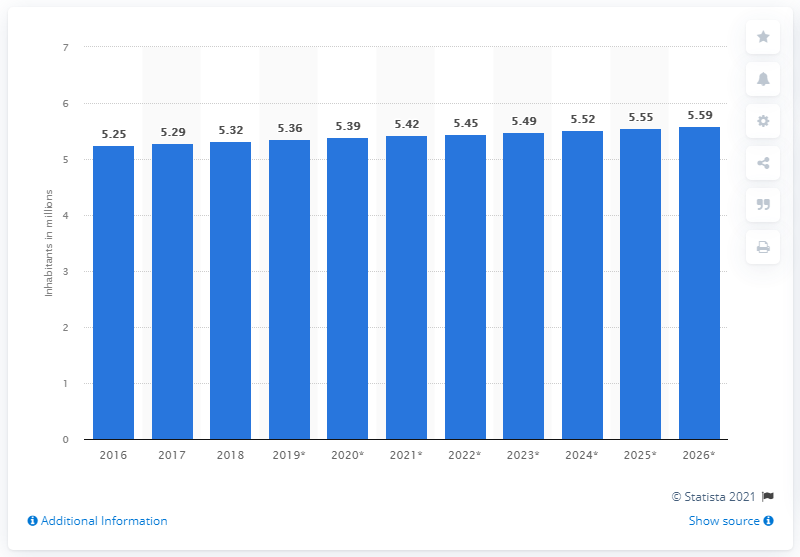Outline some significant characteristics in this image. In 2018, the population of Norway underwent a change from 2016. In 2018, the population of Norway was 5.36 million. 